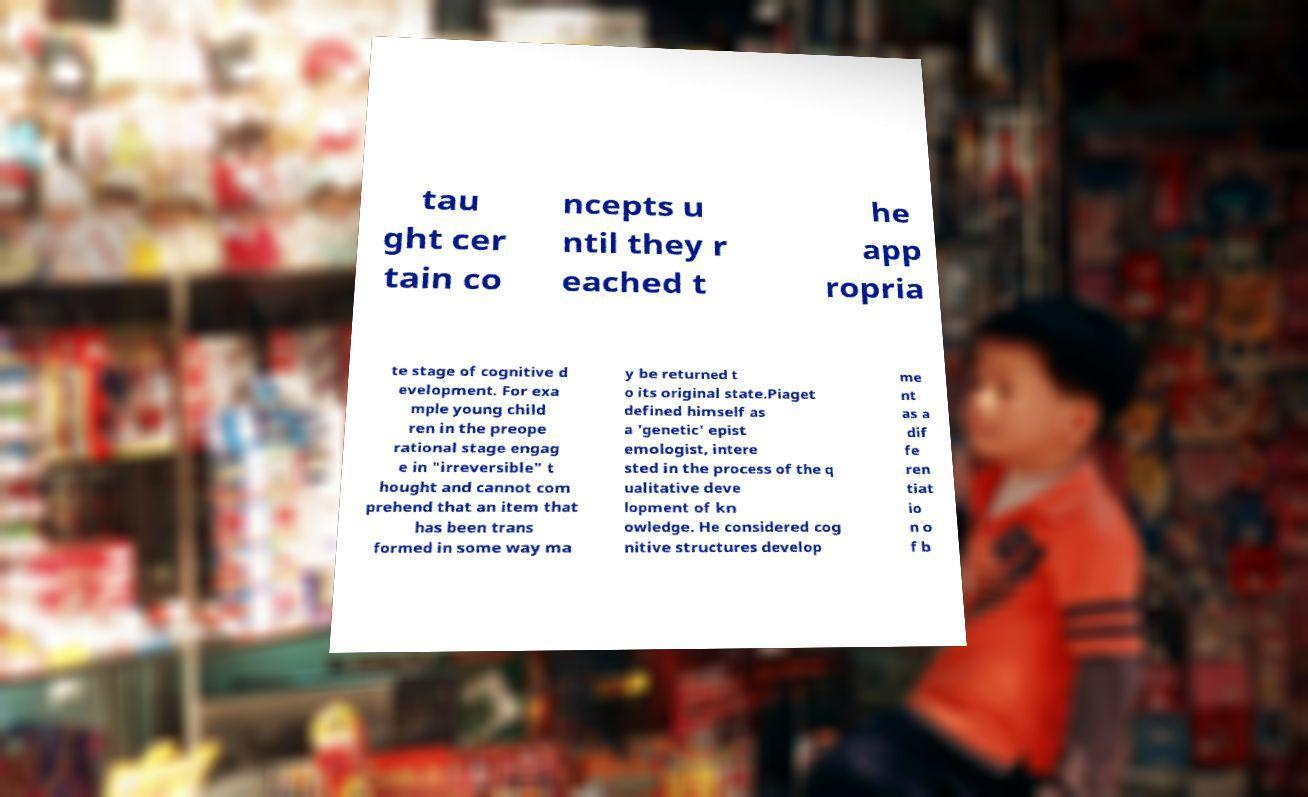Can you read and provide the text displayed in the image?This photo seems to have some interesting text. Can you extract and type it out for me? tau ght cer tain co ncepts u ntil they r eached t he app ropria te stage of cognitive d evelopment. For exa mple young child ren in the preope rational stage engag e in "irreversible" t hought and cannot com prehend that an item that has been trans formed in some way ma y be returned t o its original state.Piaget defined himself as a 'genetic' epist emologist, intere sted in the process of the q ualitative deve lopment of kn owledge. He considered cog nitive structures develop me nt as a dif fe ren tiat io n o f b 